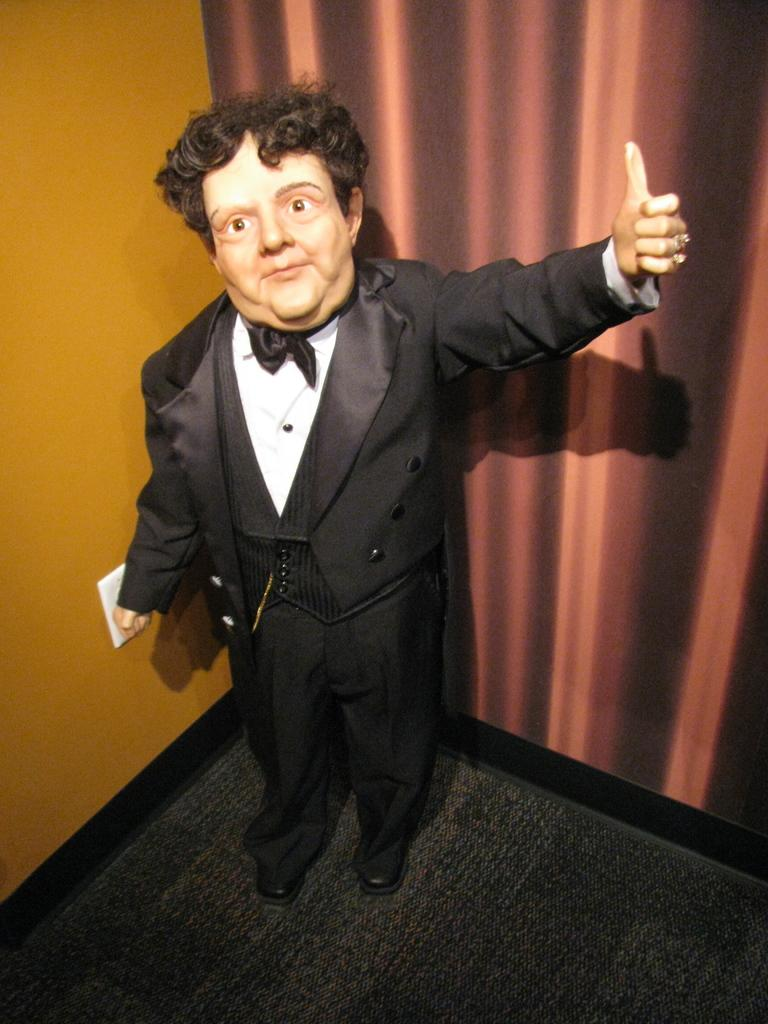What is the main subject of the image? There is a statue of a man in the image. What can be seen in the background of the image? There is a wall and a board in the background of the image. What is attached to the wall in the image? There is a switch board on the wall in the image. What is on the floor in the image? There is a mat on the floor in the image. Can you see the heart of the statue in the image? There is no heart visible in the image, as it is a statue and not a living being. Are there any plants visible in the image? There is no mention of plants in the provided facts, so we cannot determine if any are present in the image. 